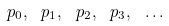<formula> <loc_0><loc_0><loc_500><loc_500>p _ { 0 } , \ p _ { 1 } , \ p _ { 2 } , \ p _ { 3 } , \ \dots</formula> 